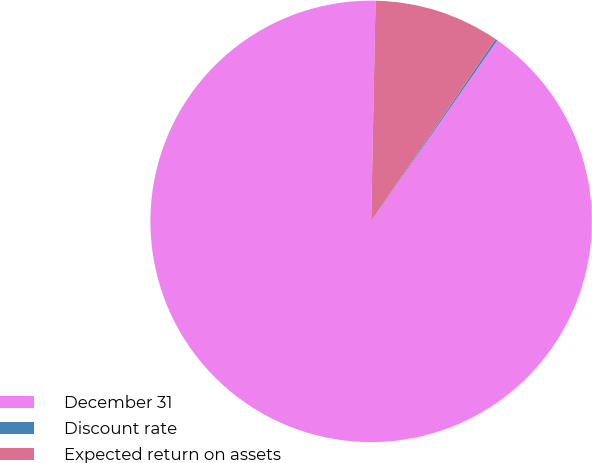Convert chart to OTSL. <chart><loc_0><loc_0><loc_500><loc_500><pie_chart><fcel>December 31<fcel>Discount rate<fcel>Expected return on assets<nl><fcel>90.63%<fcel>0.16%<fcel>9.21%<nl></chart> 